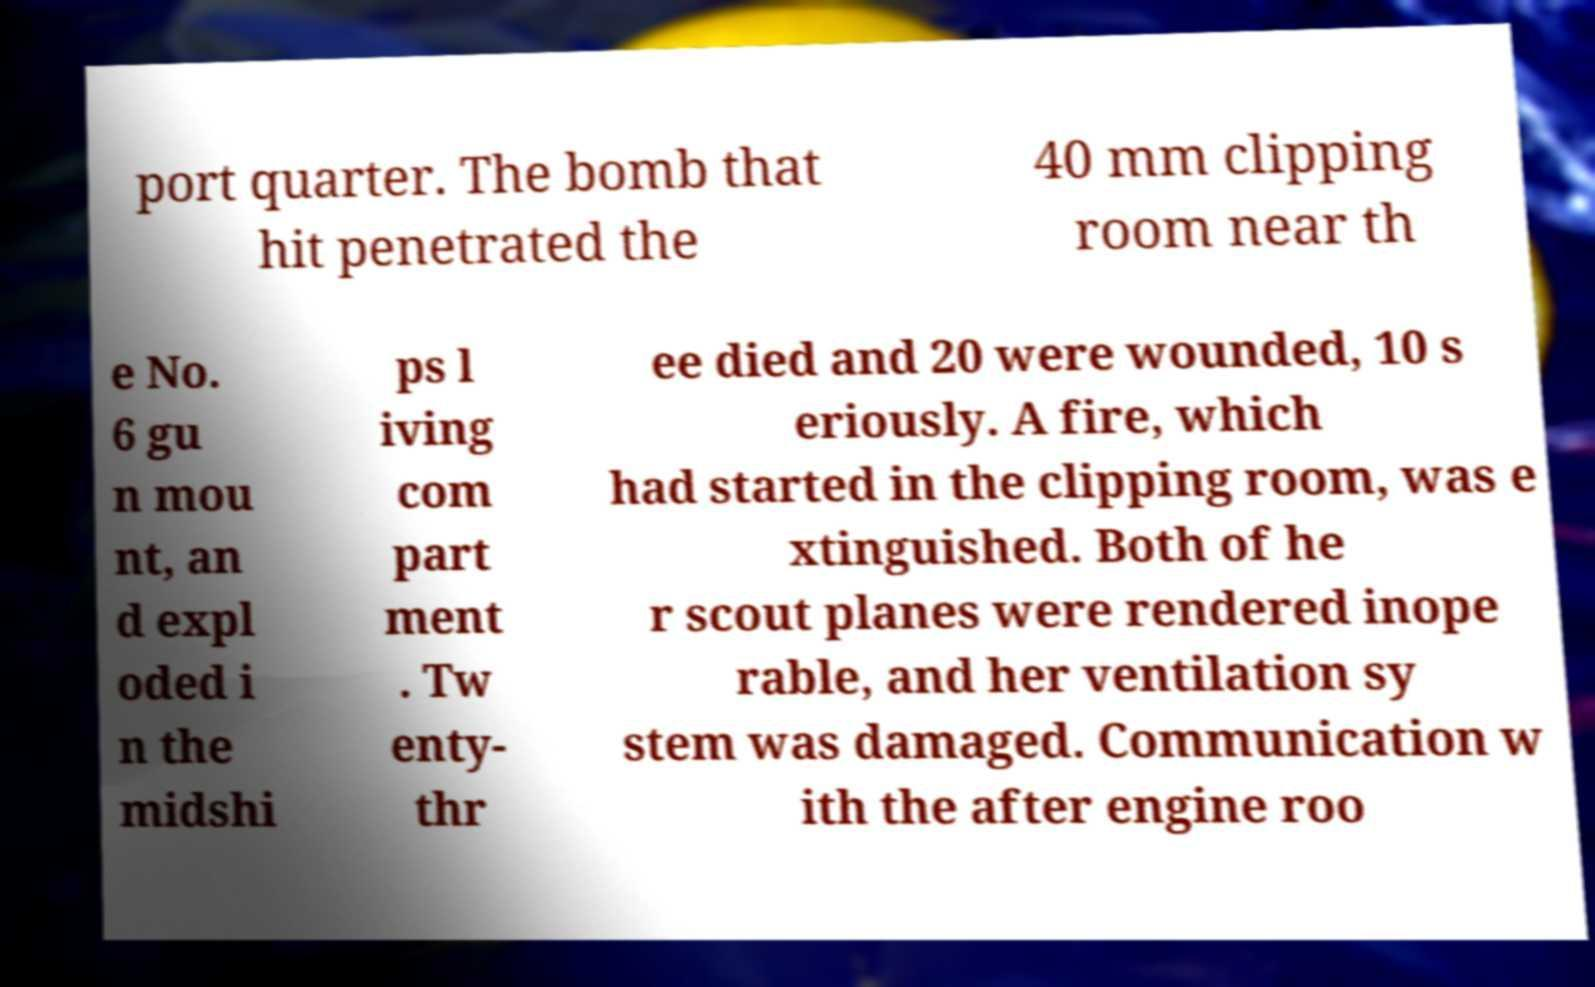Can you read and provide the text displayed in the image?This photo seems to have some interesting text. Can you extract and type it out for me? port quarter. The bomb that hit penetrated the 40 mm clipping room near th e No. 6 gu n mou nt, an d expl oded i n the midshi ps l iving com part ment . Tw enty- thr ee died and 20 were wounded, 10 s eriously. A fire, which had started in the clipping room, was e xtinguished. Both of he r scout planes were rendered inope rable, and her ventilation sy stem was damaged. Communication w ith the after engine roo 